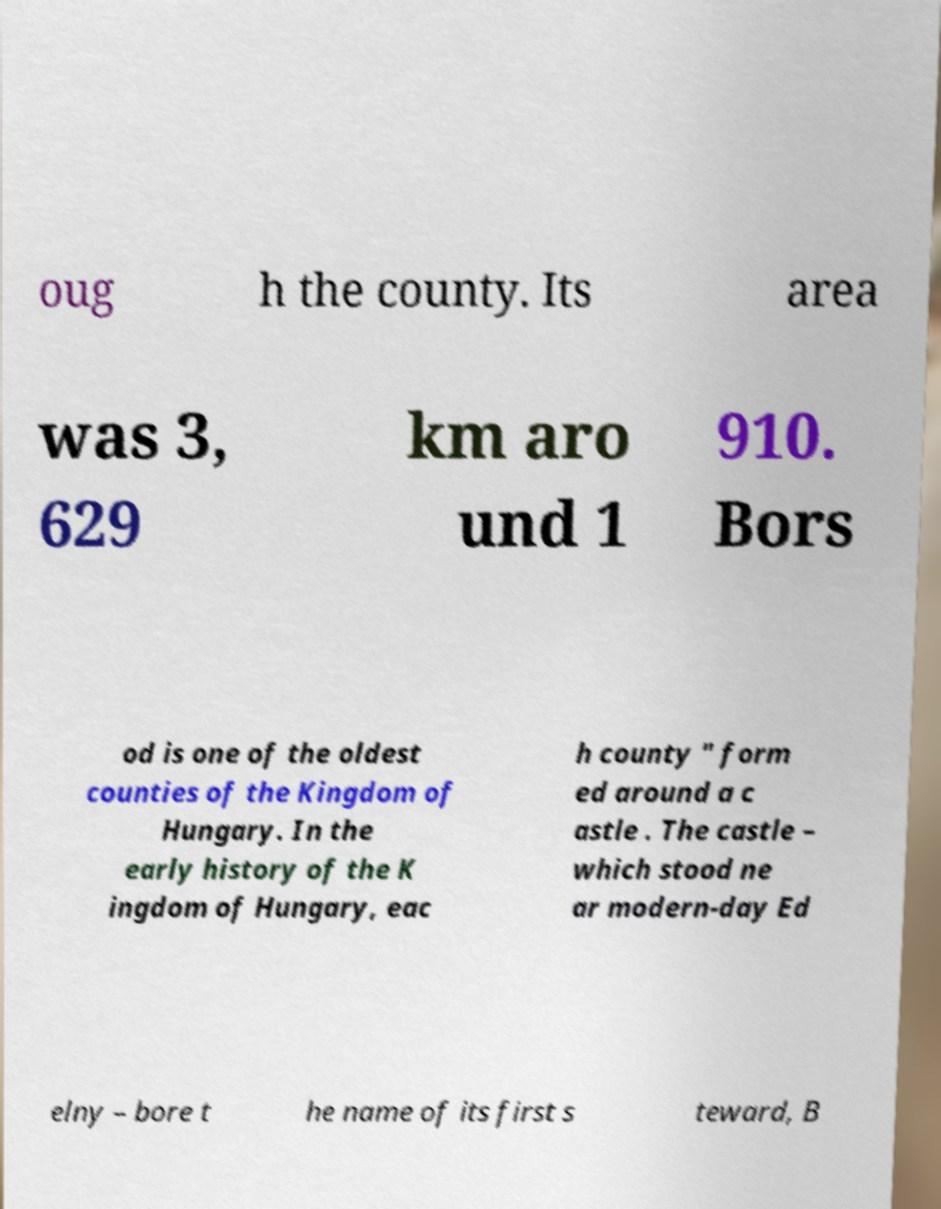Please read and relay the text visible in this image. What does it say? oug h the county. Its area was 3, 629 km aro und 1 910. Bors od is one of the oldest counties of the Kingdom of Hungary. In the early history of the K ingdom of Hungary, eac h county " form ed around a c astle . The castle – which stood ne ar modern-day Ed elny – bore t he name of its first s teward, B 